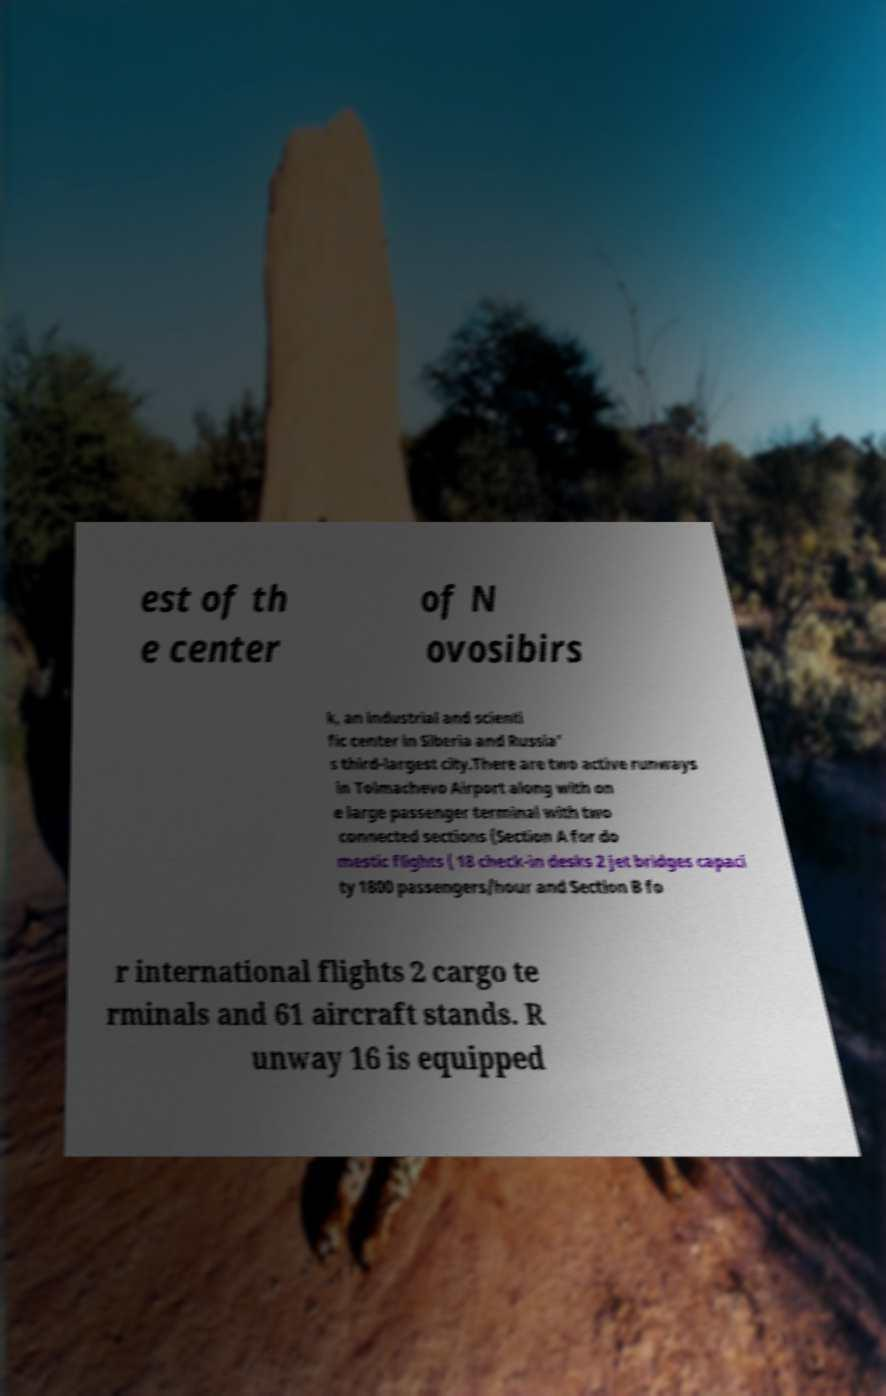What messages or text are displayed in this image? I need them in a readable, typed format. est of th e center of N ovosibirs k, an industrial and scienti fic center in Siberia and Russia' s third-largest city.There are two active runways in Tolmachevo Airport along with on e large passenger terminal with two connected sections (Section A for do mestic flights ( 18 check-in desks 2 jet bridges capaci ty 1800 passengers/hour and Section B fo r international flights 2 cargo te rminals and 61 aircraft stands. R unway 16 is equipped 